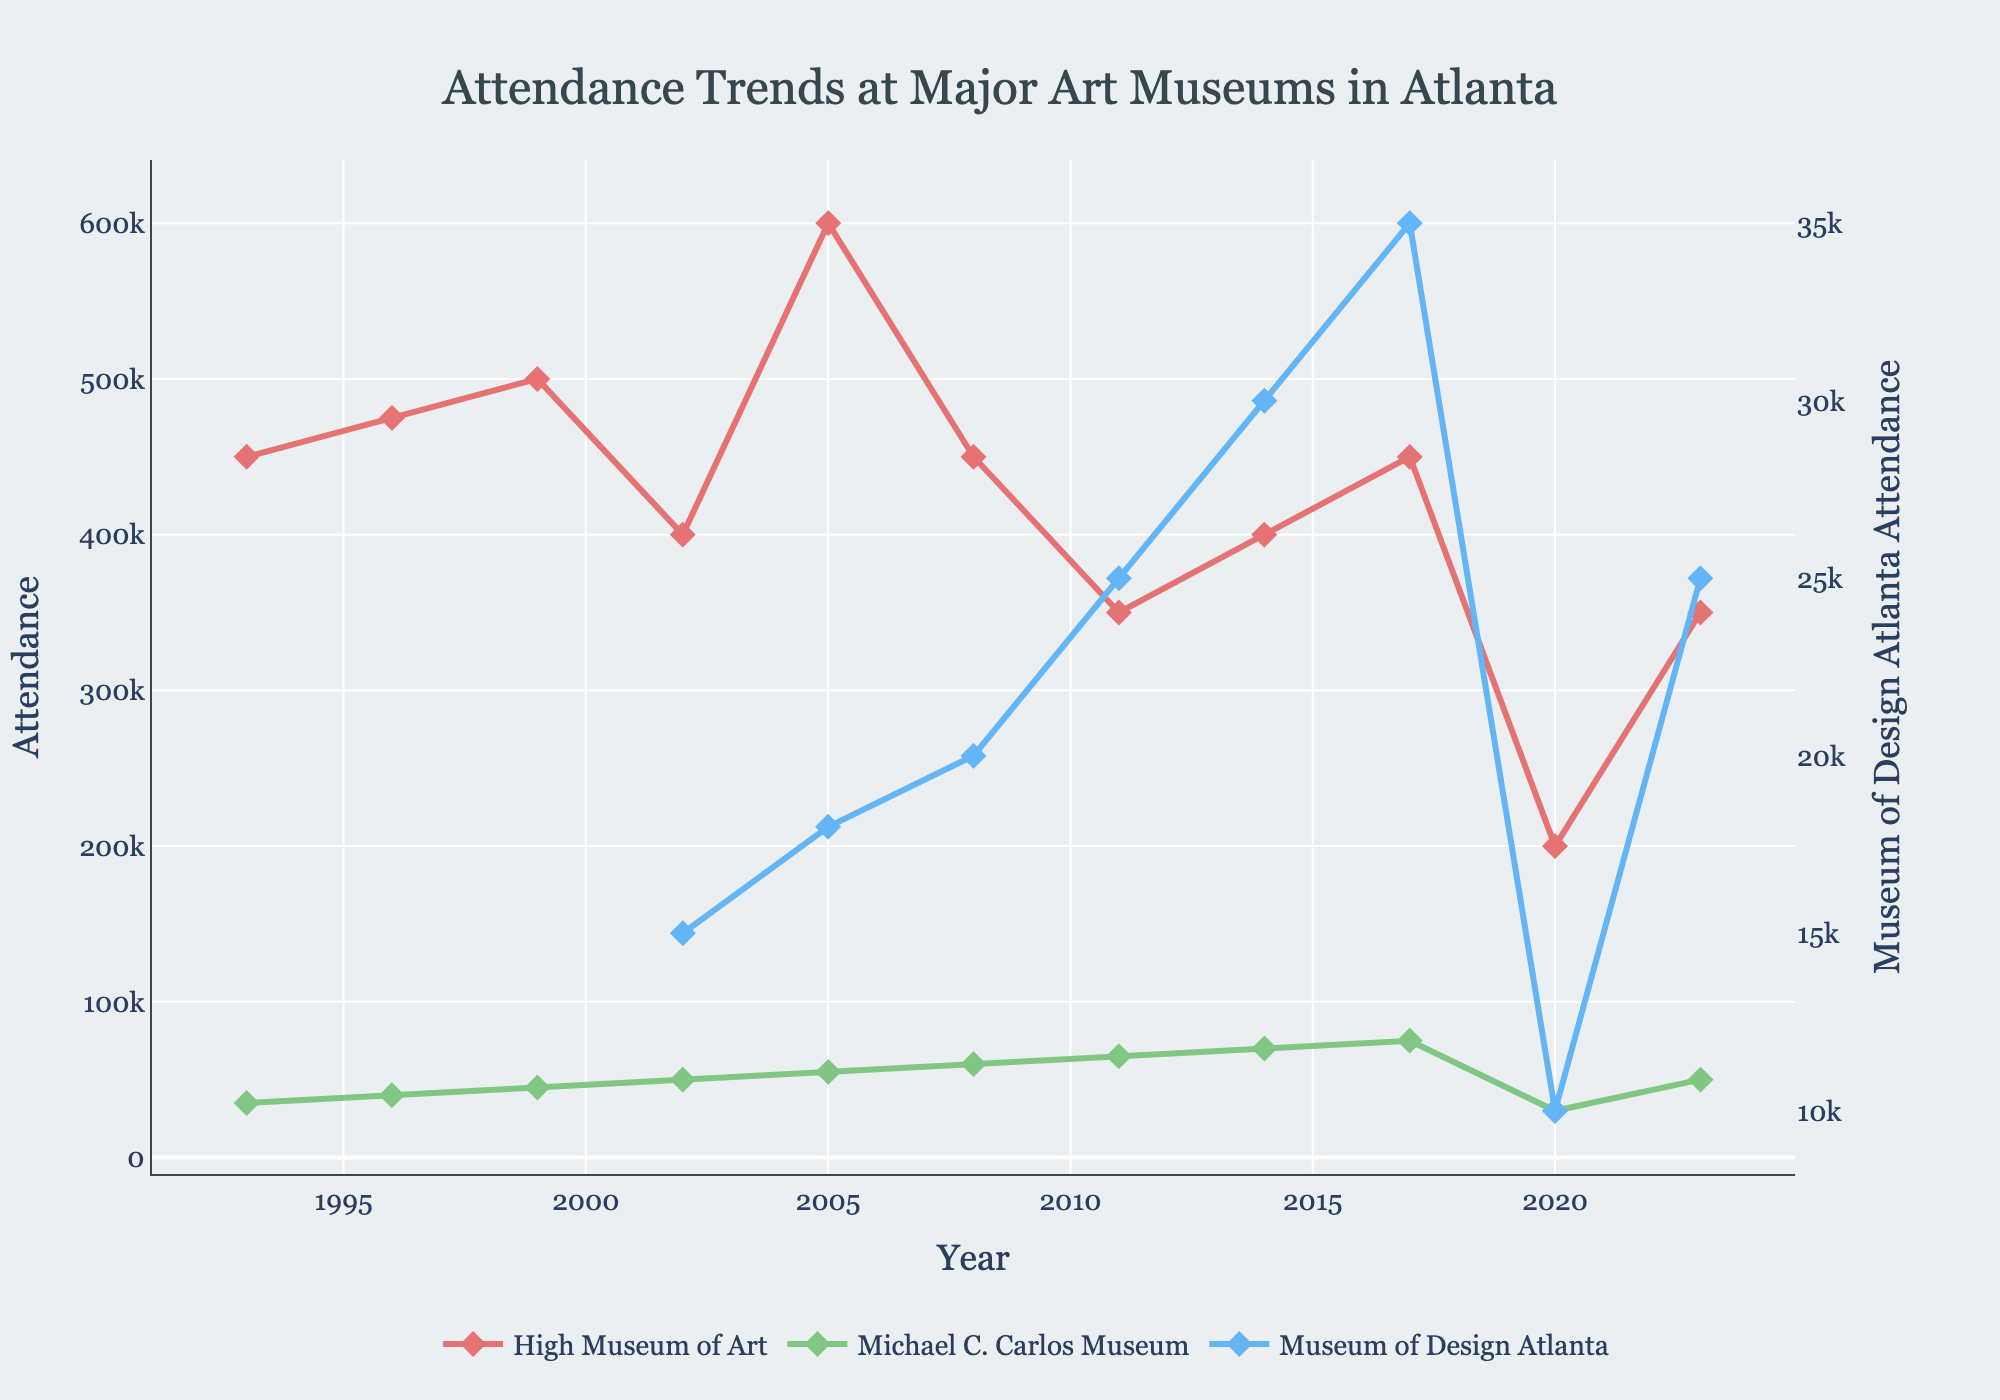What is the trend in attendance for the High Museum of Art from 1993 to 2023? The High Museum of Art shows fluctuations in attendance over the period. Attendance increased from 450,000 in 1993 to a peak of 600,000 in 2005, followed by a general decline and a significant drop in 2020, then a partial recovery by 2023.
Answer: Fluctuating with a peak in 2005 and a notable drop in 2020 What is the highest recorded attendance for the Michael C. Carlos Museum, and in what year did it occur? The highest attendance recorded for the Michael C. Carlos Museum is 75,000, which occurred in 2017. This can be seen as it is the highest point on the graph for this museum.
Answer: 75,000 in 2017 Compare the attendance of the Museum of Design Atlanta in 2008 and 2020. In 2008, the attendance for the Museum of Design Atlanta was 20,000, while in 2020, it was 10,000. This can be found by looking at the corresponding points on the graph for these years.
Answer: 20,000 in 2008, 10,000 in 2020 How did the attendance at the High Museum of Art in 2014 compare to 2017? The attendance at the High Museum of Art in 2014 was 400,000, whereas in 2017, it had increased to 450,000. This is observed from the positions of the points representing these years on the graph.
Answer: 2014: 400,000, 2017: 450,000 What is the average attendance of the Michael C. Carlos Museum from 1993 to 2023? Sum the attendance figures from 1993 to 2023 (35,000 + 40,000 + 45,000 + 50,000 + 55,000 + 60,000 + 65,000 + 70,000 + 75,000 + 30,000 + 50,000) = 575,000. Divide by the number of years (11) to find the average.
Answer: 52,273 Is there any year where all three museums had increased attendance compared to the previous period? By comparing attendance year over year, it's seen that from 2008 to 2011, all three museums show an increase in attendance: High Museum of Art (450,000 to 350,000), Michael C. Carlos Museum (60,000 to 65,000), and Museum of Design Atlanta (20,000 to 25,000).
Answer: No year meets this criterion What visual indication shows which museum had the highest attendance at its peak? The High Museum of Art can be identified by the tallest peak in the chart and has the largest values on the y-axis among all three museums, peaking at 600,000 in 2005.
Answer: High Museum of Art's tallest peak Calculate the difference in attendance between the High Museum of Art and the Michael C. Carlos Museum in 2020. By subtracting the attendance of the Michael C. Carlos Museum (30,000) from the High Museum of Art (200,000), the difference is found to be (200,000 - 30,000) = 170,000.
Answer: 170,000 How did the Museum of Design Atlanta's attendance trend compare with the Michael C. Carlos Museum from 2002 to 2023? Both museums show an increasing trend up to 2017, but with higher fluctuations and lower values for the Museum of Design Atlanta. The Michael C. Carlos Museum mostly increases steadily except for a drop in 2020.
Answer: Increasing trend for both, with higher fluctuations for the Museum of Design Atlanta Which museum had the lowest attendance in 2023, and what was the attendance? The Michael C. Carlos Museum had the lowest attendance in 2023, with 50,000. This can be verified visually by the position of the points on the graph.
Answer: Michael C. Carlos Museum: 50,000 